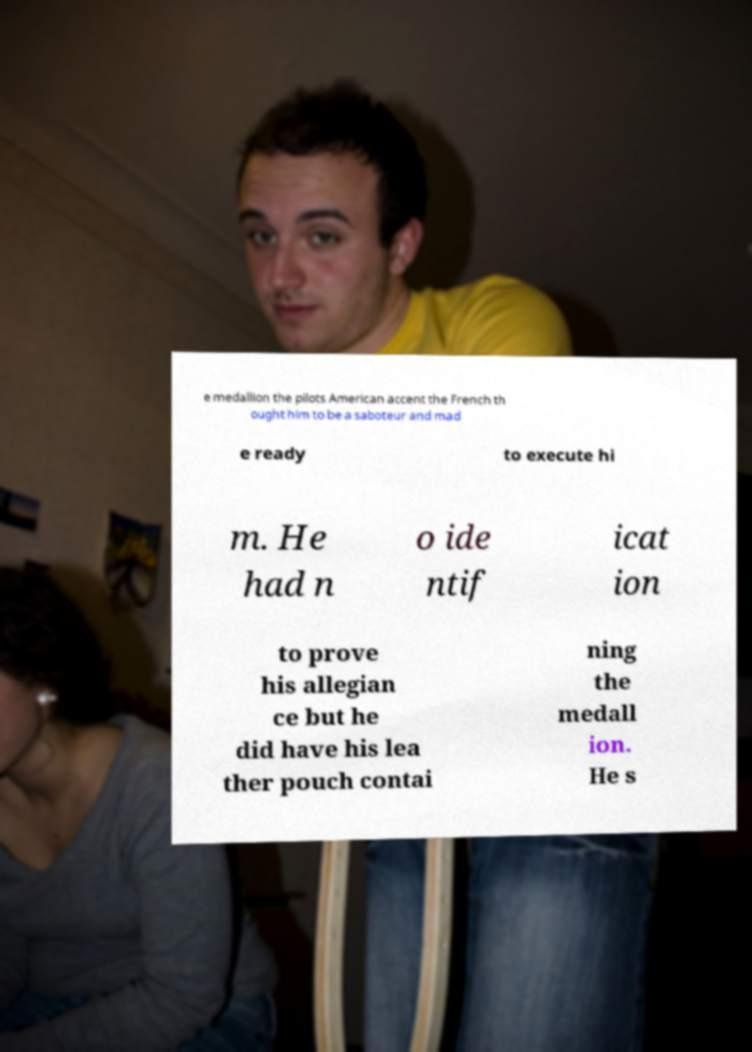Could you extract and type out the text from this image? e medallion the pilots American accent the French th ought him to be a saboteur and mad e ready to execute hi m. He had n o ide ntif icat ion to prove his allegian ce but he did have his lea ther pouch contai ning the medall ion. He s 